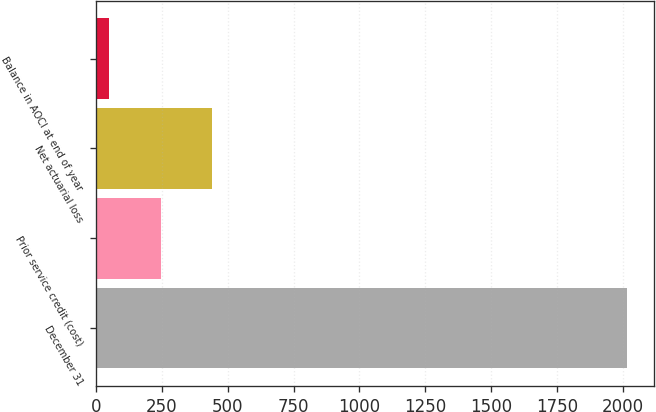Convert chart to OTSL. <chart><loc_0><loc_0><loc_500><loc_500><bar_chart><fcel>December 31<fcel>Prior service credit (cost)<fcel>Net actuarial loss<fcel>Balance in AOCI at end of year<nl><fcel>2016<fcel>244.8<fcel>441.6<fcel>48<nl></chart> 